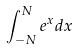<formula> <loc_0><loc_0><loc_500><loc_500>\int _ { - N } ^ { N } e ^ { x } d x</formula> 